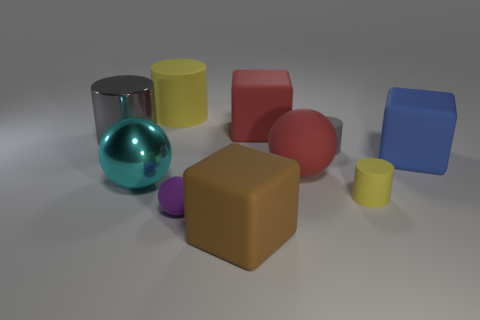What is the size of the rubber thing that is both on the left side of the big brown object and in front of the small yellow thing?
Offer a very short reply. Small. The matte object that is the same color as the metallic cylinder is what shape?
Give a very brief answer. Cylinder. What color is the big metal sphere?
Your answer should be compact. Cyan. There is a metallic cylinder behind the purple object; how big is it?
Offer a very short reply. Large. There is a yellow thing to the left of the large object that is in front of the purple thing; what number of large brown rubber things are on the left side of it?
Offer a terse response. 0. What color is the large object right of the gray cylinder on the right side of the purple ball?
Your answer should be compact. Blue. Is there a brown rubber thing of the same size as the cyan metal object?
Provide a short and direct response. Yes. What material is the large block that is in front of the yellow cylinder that is on the right side of the rubber object to the left of the small sphere made of?
Your response must be concise. Rubber. How many shiny cylinders are in front of the gray thing behind the tiny gray rubber object?
Give a very brief answer. 0. There is a matte block that is on the right side of the red matte cube; does it have the same size as the large brown matte block?
Your answer should be very brief. Yes. 